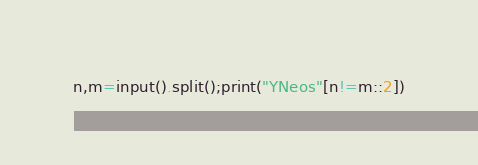<code> <loc_0><loc_0><loc_500><loc_500><_Python_>n,m=input().split();print("YNeos"[n!=m::2])</code> 